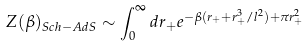<formula> <loc_0><loc_0><loc_500><loc_500>Z ( \beta ) _ { S c h - A d S } \sim \int _ { 0 } ^ { \infty } d r _ { + } e ^ { - \beta ( r _ { + } + r _ { + } ^ { 3 } / l ^ { 2 } ) + \pi r ^ { 2 } _ { + } }</formula> 